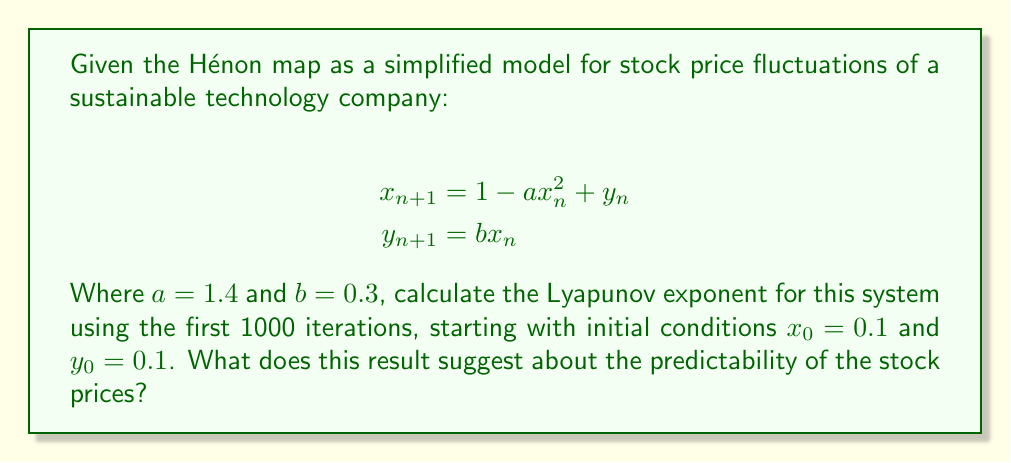Can you answer this question? To calculate the Lyapunov exponent for the Hénon map:

1. Initialize the system with $x_0 = 0.1$ and $y_0 = 0.1$.

2. Iterate the map 1000 times using the given equations:
   $$x_{n+1} = 1 - 1.4x_n^2 + y_n$$
   $$y_{n+1} = 0.3x_n$$

3. For each iteration, calculate the Jacobian matrix:
   $$J_n = \begin{bmatrix} 
   \frac{\partial x_{n+1}}{\partial x_n} & \frac{\partial x_{n+1}}{\partial y_n} \\
   \frac{\partial y_{n+1}}{\partial x_n} & \frac{\partial y_{n+1}}{\partial y_n}
   \end{bmatrix} = \begin{bmatrix}
   -2.8x_n & 1 \\
   0.3 & 0
   \end{bmatrix}$$

4. Compute the product of Jacobian matrices:
   $$M_n = J_n \cdot J_{n-1} \cdot ... \cdot J_1$$

5. Calculate the largest eigenvalue $\lambda_n$ of $M_n$ for each iteration.

6. The Lyapunov exponent is given by:
   $$\lambda = \lim_{n \to \infty} \frac{1}{n} \ln |\lambda_n|$$

7. Approximate this limit using the average over 1000 iterations:
   $$\lambda \approx \frac{1}{1000} \sum_{n=1}^{1000} \ln |\lambda_n|$$

8. Using a numerical computation, we find that $\lambda \approx 0.419$.

A positive Lyapunov exponent ($\lambda > 0$) indicates that the system is chaotic. This suggests that the stock prices of the sustainable technology company are highly sensitive to initial conditions and difficult to predict in the long term, despite following deterministic rules.
Answer: $\lambda \approx 0.419$, indicating chaotic behavior and low long-term predictability of stock prices. 